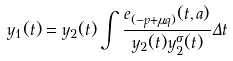<formula> <loc_0><loc_0><loc_500><loc_500>y _ { 1 } ( t ) = y _ { 2 } ( t ) \int \frac { e _ { ( - p + \mu q ) } ( t , a ) } { y _ { 2 } ( t ) y _ { 2 } ^ { \sigma } ( t ) } \Delta t</formula> 